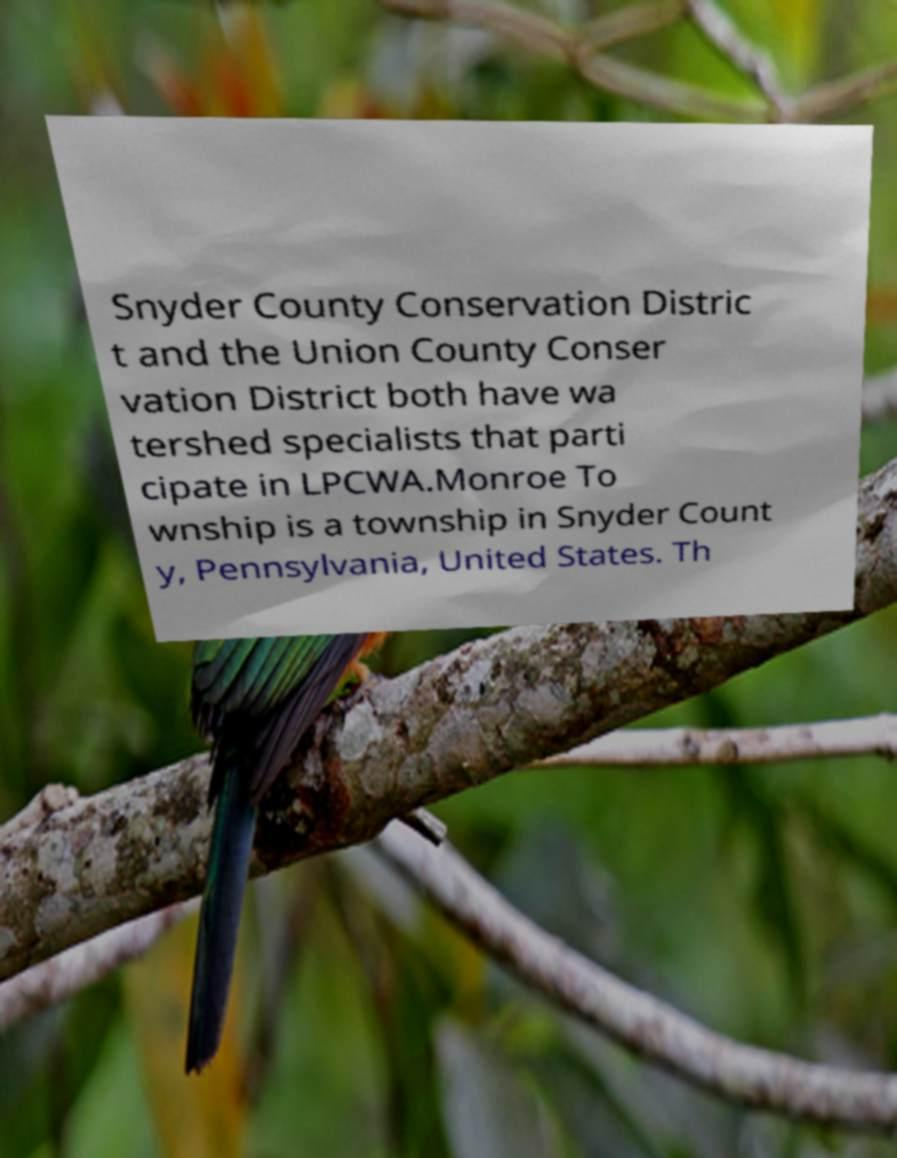Could you assist in decoding the text presented in this image and type it out clearly? Snyder County Conservation Distric t and the Union County Conser vation District both have wa tershed specialists that parti cipate in LPCWA.Monroe To wnship is a township in Snyder Count y, Pennsylvania, United States. Th 